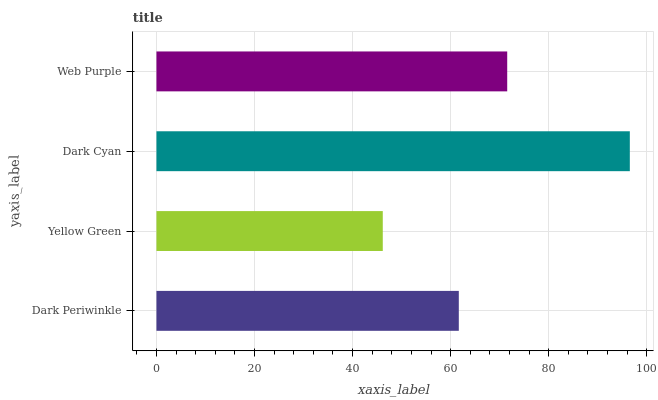Is Yellow Green the minimum?
Answer yes or no. Yes. Is Dark Cyan the maximum?
Answer yes or no. Yes. Is Dark Cyan the minimum?
Answer yes or no. No. Is Yellow Green the maximum?
Answer yes or no. No. Is Dark Cyan greater than Yellow Green?
Answer yes or no. Yes. Is Yellow Green less than Dark Cyan?
Answer yes or no. Yes. Is Yellow Green greater than Dark Cyan?
Answer yes or no. No. Is Dark Cyan less than Yellow Green?
Answer yes or no. No. Is Web Purple the high median?
Answer yes or no. Yes. Is Dark Periwinkle the low median?
Answer yes or no. Yes. Is Dark Periwinkle the high median?
Answer yes or no. No. Is Web Purple the low median?
Answer yes or no. No. 